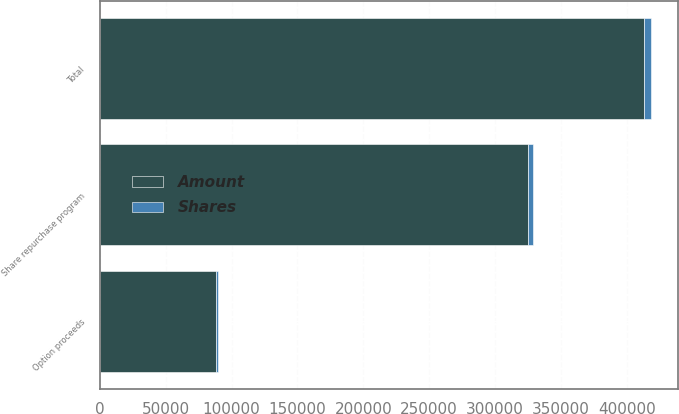<chart> <loc_0><loc_0><loc_500><loc_500><stacked_bar_chart><ecel><fcel>Share repurchase program<fcel>Option proceeds<fcel>Total<nl><fcel>Shares<fcel>4126<fcel>1103<fcel>5229<nl><fcel>Amount<fcel>324622<fcel>88367<fcel>412989<nl></chart> 